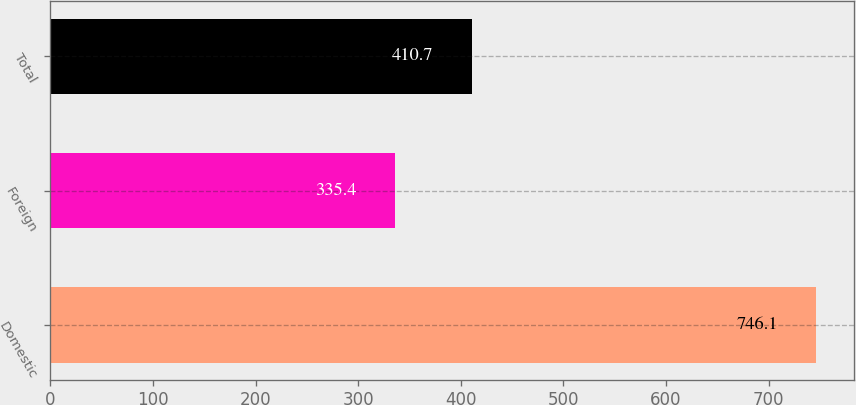<chart> <loc_0><loc_0><loc_500><loc_500><bar_chart><fcel>Domestic<fcel>Foreign<fcel>Total<nl><fcel>746.1<fcel>335.4<fcel>410.7<nl></chart> 